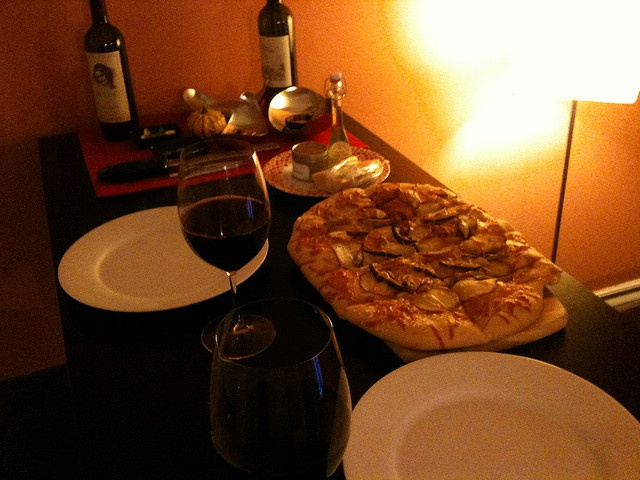Describe the objects in this image and their specific colors. I can see dining table in maroon, black, and brown tones, pizza in maroon, brown, and black tones, wine glass in maroon, black, brown, and navy tones, wine glass in maroon, black, and brown tones, and bottle in maroon, black, and brown tones in this image. 